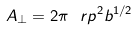Convert formula to latex. <formula><loc_0><loc_0><loc_500><loc_500>A _ { \perp } = 2 \pi \ r p ^ { 2 } b ^ { 1 / 2 }</formula> 